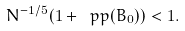<formula> <loc_0><loc_0><loc_500><loc_500>N ^ { - 1 / 5 } ( 1 + \ p p ( B _ { 0 } ) ) < 1 .</formula> 